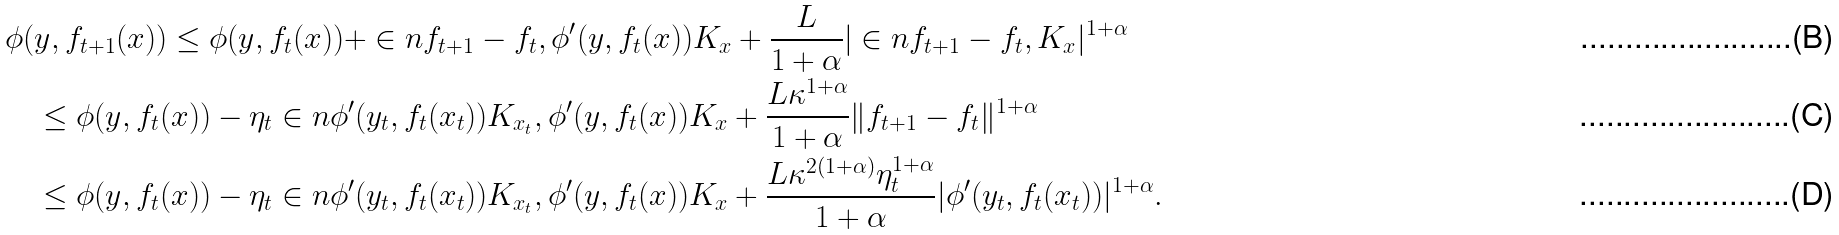Convert formula to latex. <formula><loc_0><loc_0><loc_500><loc_500>& \phi ( y , f _ { t + 1 } ( x ) ) \leq \phi ( y , f _ { t } ( x ) ) + \in n { f _ { t + 1 } - f _ { t } , \phi ^ { \prime } ( y , f _ { t } ( x ) ) K _ { x } } + \frac { L } { 1 + \alpha } | \in n { f _ { t + 1 } - f _ { t } , K _ { x } } | ^ { 1 + \alpha } \\ & \quad \leq \phi ( y , f _ { t } ( x ) ) - \eta _ { t } \in n { \phi ^ { \prime } ( y _ { t } , f _ { t } ( x _ { t } ) ) K _ { x _ { t } } , \phi ^ { \prime } ( y , f _ { t } ( x ) ) K _ { x } } + \frac { L \kappa ^ { 1 + \alpha } } { 1 + \alpha } \| f _ { t + 1 } - f _ { t } \| ^ { 1 + \alpha } \\ & \quad \leq \phi ( y , f _ { t } ( x ) ) - \eta _ { t } \in n { \phi ^ { \prime } ( y _ { t } , f _ { t } ( x _ { t } ) ) K _ { x _ { t } } , \phi ^ { \prime } ( y , f _ { t } ( x ) ) K _ { x } } + \frac { L \kappa ^ { 2 ( 1 + \alpha ) } \eta _ { t } ^ { 1 + \alpha } } { 1 + \alpha } | \phi ^ { \prime } ( y _ { t } , f _ { t } ( x _ { t } ) ) | ^ { 1 + \alpha } .</formula> 